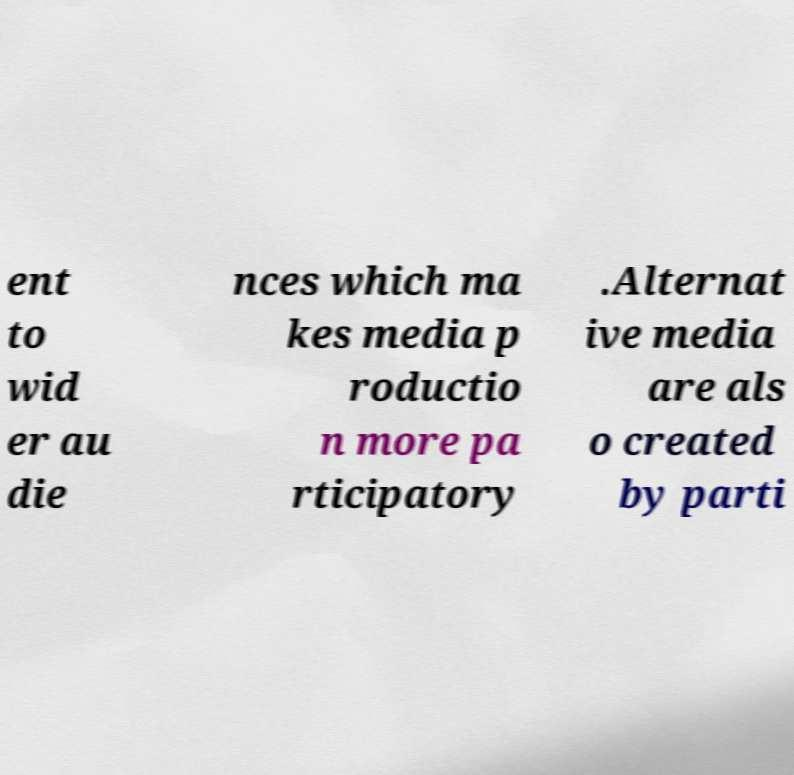There's text embedded in this image that I need extracted. Can you transcribe it verbatim? ent to wid er au die nces which ma kes media p roductio n more pa rticipatory .Alternat ive media are als o created by parti 